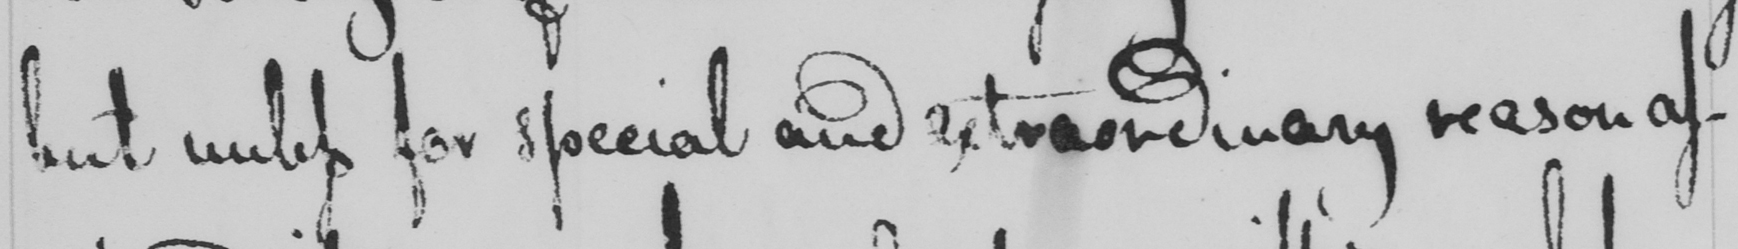Transcribe the text shown in this historical manuscript line. but unless for special and extraordinary reason as- 